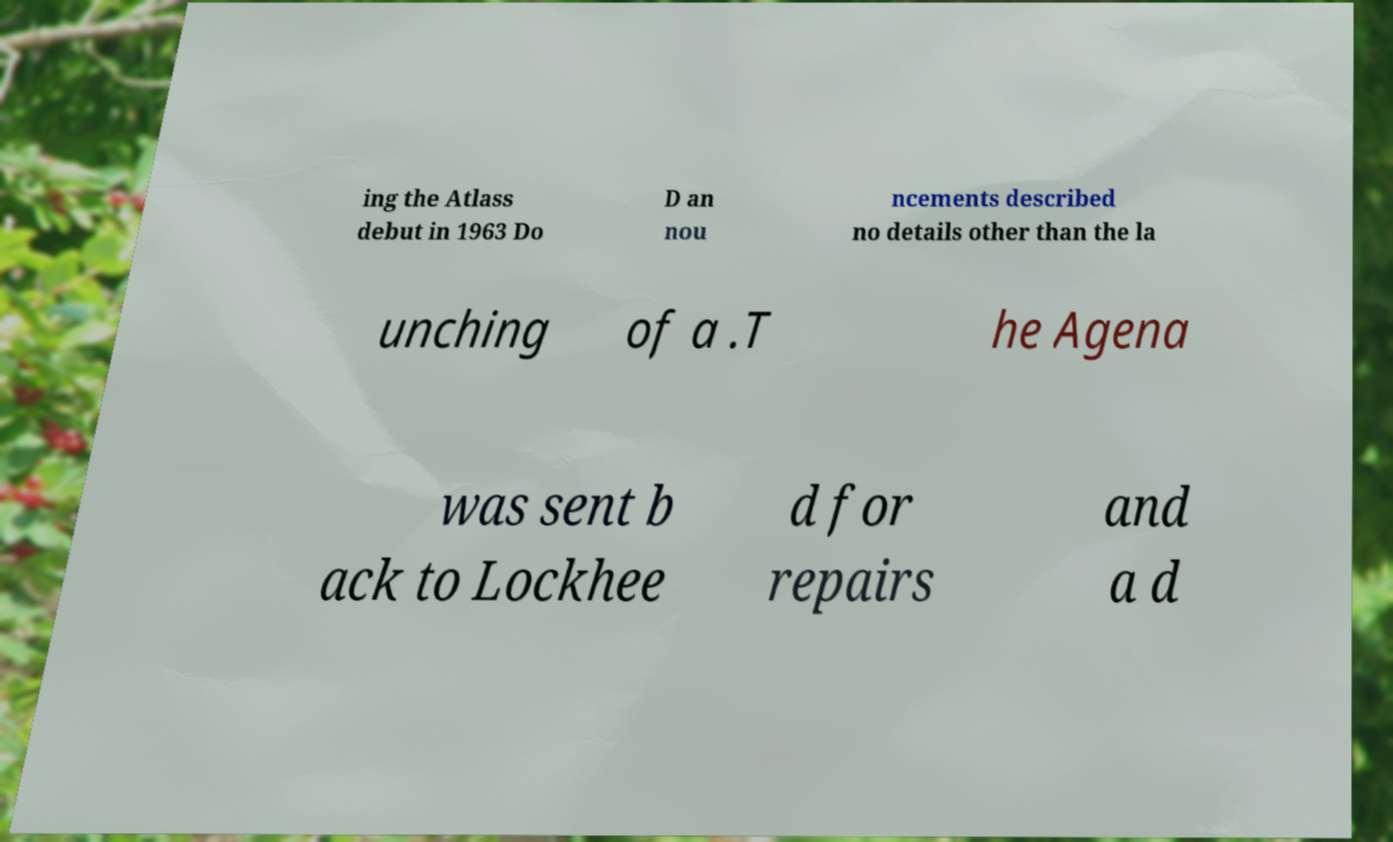Can you read and provide the text displayed in the image?This photo seems to have some interesting text. Can you extract and type it out for me? ing the Atlass debut in 1963 Do D an nou ncements described no details other than the la unching of a .T he Agena was sent b ack to Lockhee d for repairs and a d 